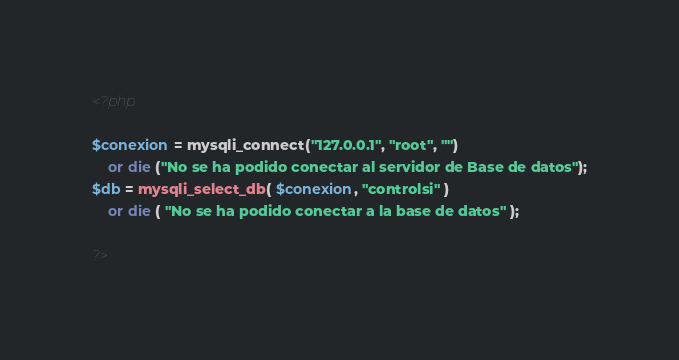<code> <loc_0><loc_0><loc_500><loc_500><_PHP_><?php

$conexion = mysqli_connect("127.0.0.1", "root", "")
    or die ("No se ha podido conectar al servidor de Base de datos");
$db = mysqli_select_db( $conexion, "controlsi" )
    or die ( "No se ha podido conectar a la base de datos" );

?></code> 